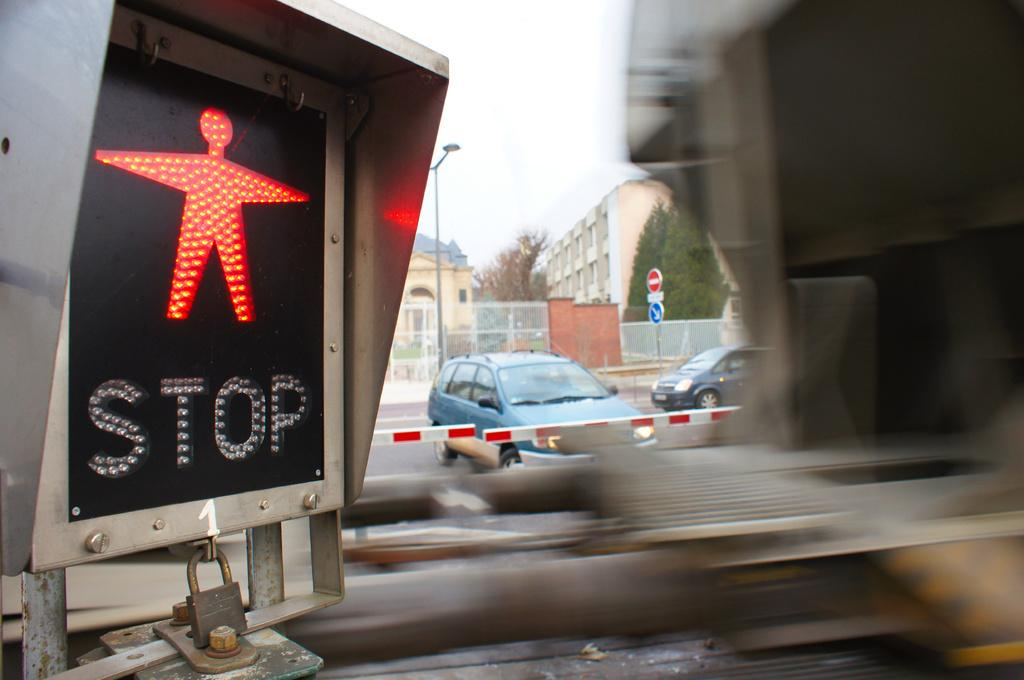<image>
Write a terse but informative summary of the picture. Stop sign for a person walking on the highway 